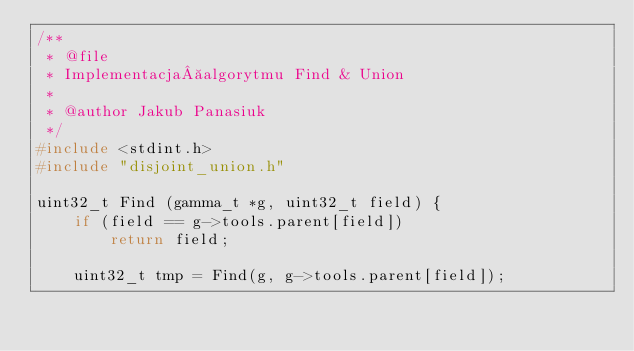Convert code to text. <code><loc_0><loc_0><loc_500><loc_500><_C_>/**
 * @file
 * Implementacja algorytmu Find & Union
 *
 * @author Jakub Panasiuk
 */
#include <stdint.h>
#include "disjoint_union.h"

uint32_t Find (gamma_t *g, uint32_t field) {
    if (field == g->tools.parent[field])
        return field;

    uint32_t tmp = Find(g, g->tools.parent[field]);</code> 